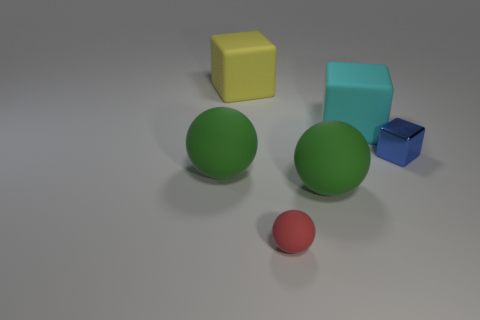Add 2 blue metal balls. How many objects exist? 8 Subtract all blue metallic blocks. How many blocks are left? 2 Subtract 1 blocks. How many blocks are left? 2 Subtract 1 cyan cubes. How many objects are left? 5 Subtract all blue cubes. Subtract all purple cylinders. How many cubes are left? 2 Subtract all brown spheres. How many blue blocks are left? 1 Subtract all tiny blue objects. Subtract all cubes. How many objects are left? 2 Add 3 large objects. How many large objects are left? 7 Add 3 gray shiny objects. How many gray shiny objects exist? 3 Subtract all green spheres. How many spheres are left? 1 